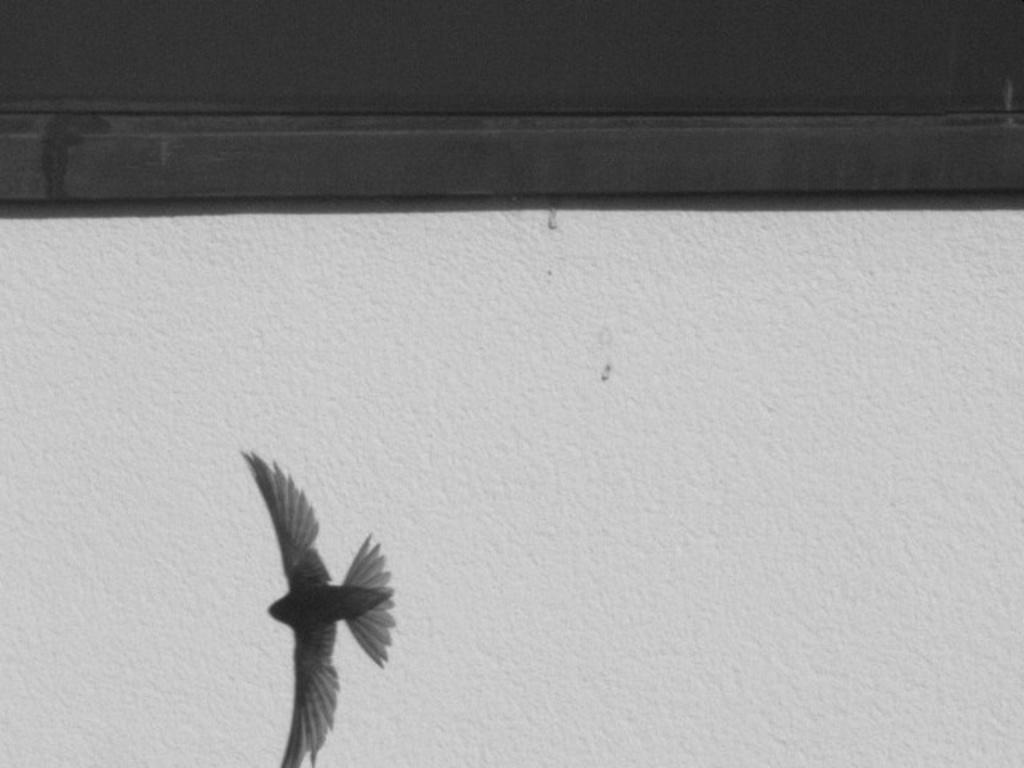What is the main subject of the image? The main subject of the image is a bird flying. Where is the bird located in the image? The bird is at the bottom of the image. What can be seen in the background of the image? There is a wall in the image. What is present at the top of the image? There is a wooden plank at the top of the image. How many snails are crawling on the wooden plank in the image? There are no snails present in the image; it only features a bird flying and a wooden plank. What type of pot is visible on the wall in the image? There is no pot visible on the wall in the image; only a bird flying, a wall, and a wooden plank are present. 